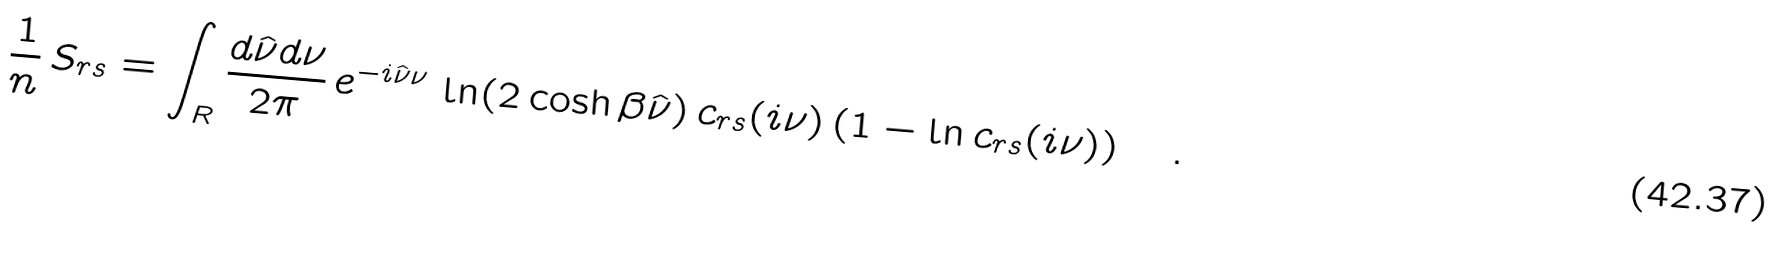<formula> <loc_0><loc_0><loc_500><loc_500>\frac { 1 } { n } \, S _ { r s } = \int _ { R } \frac { d \hat { \nu } d \nu } { 2 \pi } \, e ^ { - i \hat { \nu } \nu } \, \ln ( 2 \cosh \beta \hat { \nu } ) \, c _ { r s } ( i \nu ) \left ( 1 - \ln c _ { r s } ( i \nu ) \right ) \quad .</formula> 